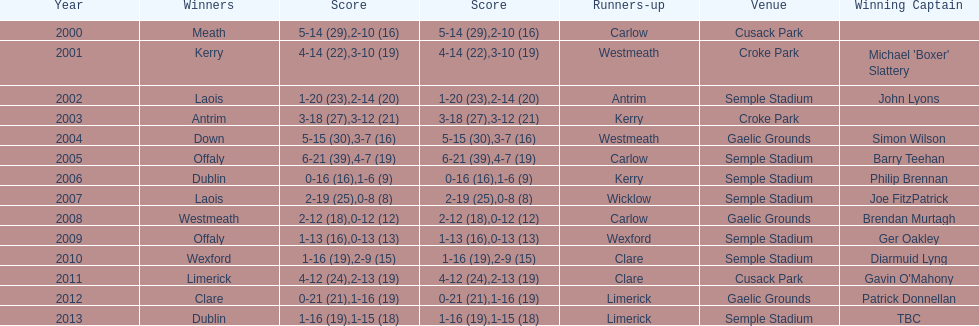How do the scores from 2000 vary? 13. 